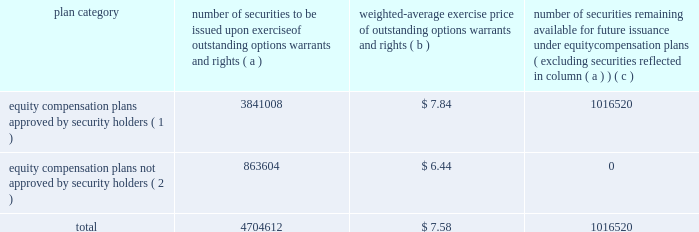Part iii item 10 .
Directors and executive officers of the registrant .
Pursuant to section 406 of the sarbanes-oxley act of 2002 , we have adopted a code of ethics for senior financial officers that applies to our principal executive officer and principal financial officer , principal accounting officer and controller , and other persons performing similar functions .
Our code of ethics for senior financial officers is publicly available on our website at www.hologic.com .
We intend to satisfy the disclosure requirement under item 5.05 of current report on form 8-k regarding an amendment to , or waiver from , a provision of this code by posting such information on our website , at the address specified above .
The additional information required by this item is incorporated by reference to our definitive proxy statement for our annual meeting of stockholders to be filed with the securities and exchange commission within 120 days after the close of our fiscal year .
Item 11 .
Executive compensation .
The information required by this item is incorporated by reference to our definitive proxy statement for our annual meeting of stockholders to be filed with the securities and exchange commission within 120 days after the close of our fiscal year .
Item 12 .
Security ownership of certain beneficial owners and management and related stockholder matters .
We maintain a number of equity compensation plans for employees , officers , directors and others whose efforts contribute to our success .
The table below sets forth certain information as our fiscal year ended september 24 , 2005 regarding the shares of our common stock available for grant or granted under stock option plans that ( i ) were approved by our stockholders , and ( ii ) were not approved by our stockholders .
The number of securities and the exercise price of the outstanding securities have been adjusted to reflect our two-for-one stock split effected on november 30 , 2005 .
Equity compensation plan information plan category number of securities to be issued upon exercise of outstanding options , warrants and rights weighted-average exercise price of outstanding options , warrants and rights number of securities remaining available for future issuance under equity compensation plans ( excluding securities reflected in column ( a ) ) equity compensation plans approved by security holders ( 1 ) .
3841008 $ 7.84 1016520 equity compensation plans not approved by security holders ( 2 ) .
863604 $ 6.44 0 .
( 1 ) includes the following plans : 1986 combination stock option plan ; amended and restated 1990 non-employee director stock option plan ; 1995 combination stock option plan ; amended and restated 1999 equity incentive plan ; and 2000 employee stock purchase plan .
Also includes the following plans which we assumed in connection with our acquisition of fluoroscan imaging systems in 1996 : fluoroscan imaging systems , inc .
1994 amended and restated stock incentive plan and fluoroscan imaging systems , inc .
1995 stock incentive plan .
For a description of these plans , please refer to footnote 5 contained in our consolidated financial statements. .
What portion of the total number of issues securities is not approved by security holders? 
Computations: (863604 / 4704612)
Answer: 0.18357. 